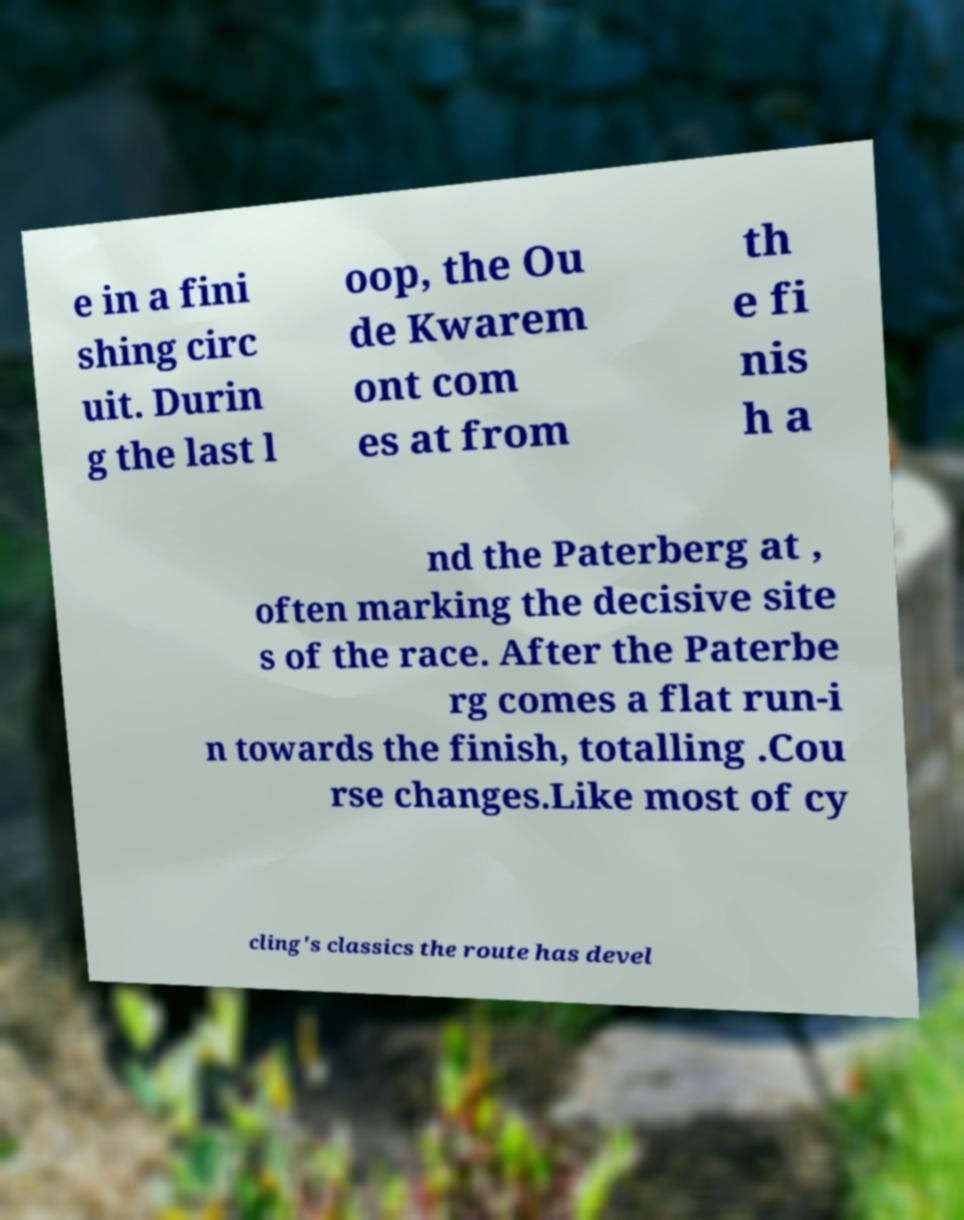For documentation purposes, I need the text within this image transcribed. Could you provide that? e in a fini shing circ uit. Durin g the last l oop, the Ou de Kwarem ont com es at from th e fi nis h a nd the Paterberg at , often marking the decisive site s of the race. After the Paterbe rg comes a flat run-i n towards the finish, totalling .Cou rse changes.Like most of cy cling's classics the route has devel 